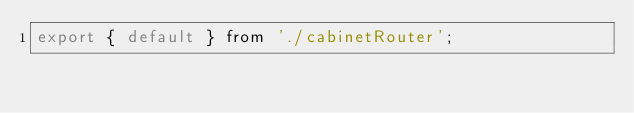Convert code to text. <code><loc_0><loc_0><loc_500><loc_500><_JavaScript_>export { default } from './cabinetRouter';
</code> 